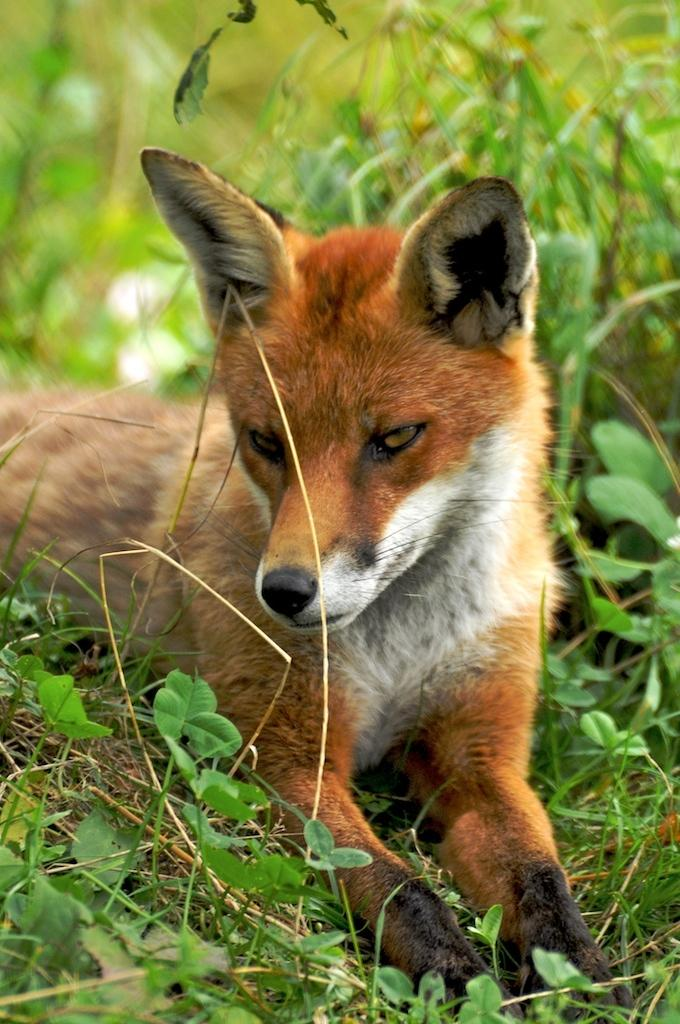What type of animal is present in the image? There is a dog in the image. Where is the dog located in the image? The dog is on the ground in the image. What type of vegetation can be seen in the image? There are plants and grass visible in the image. What shape is the yarn that the dog is holding in the image? There is no yarn present in the image, and therefore no shape can be determined. 